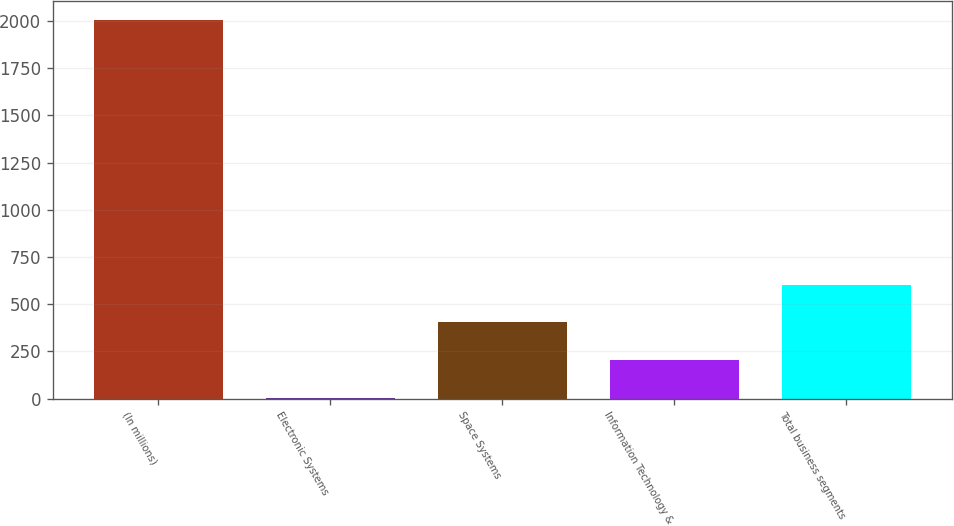Convert chart to OTSL. <chart><loc_0><loc_0><loc_500><loc_500><bar_chart><fcel>(In millions)<fcel>Electronic Systems<fcel>Space Systems<fcel>Information Technology &<fcel>Total business segments<nl><fcel>2005<fcel>4<fcel>404.2<fcel>204.1<fcel>604.3<nl></chart> 